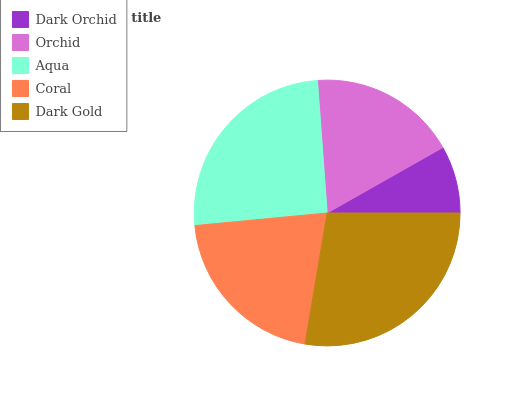Is Dark Orchid the minimum?
Answer yes or no. Yes. Is Dark Gold the maximum?
Answer yes or no. Yes. Is Orchid the minimum?
Answer yes or no. No. Is Orchid the maximum?
Answer yes or no. No. Is Orchid greater than Dark Orchid?
Answer yes or no. Yes. Is Dark Orchid less than Orchid?
Answer yes or no. Yes. Is Dark Orchid greater than Orchid?
Answer yes or no. No. Is Orchid less than Dark Orchid?
Answer yes or no. No. Is Coral the high median?
Answer yes or no. Yes. Is Coral the low median?
Answer yes or no. Yes. Is Aqua the high median?
Answer yes or no. No. Is Aqua the low median?
Answer yes or no. No. 